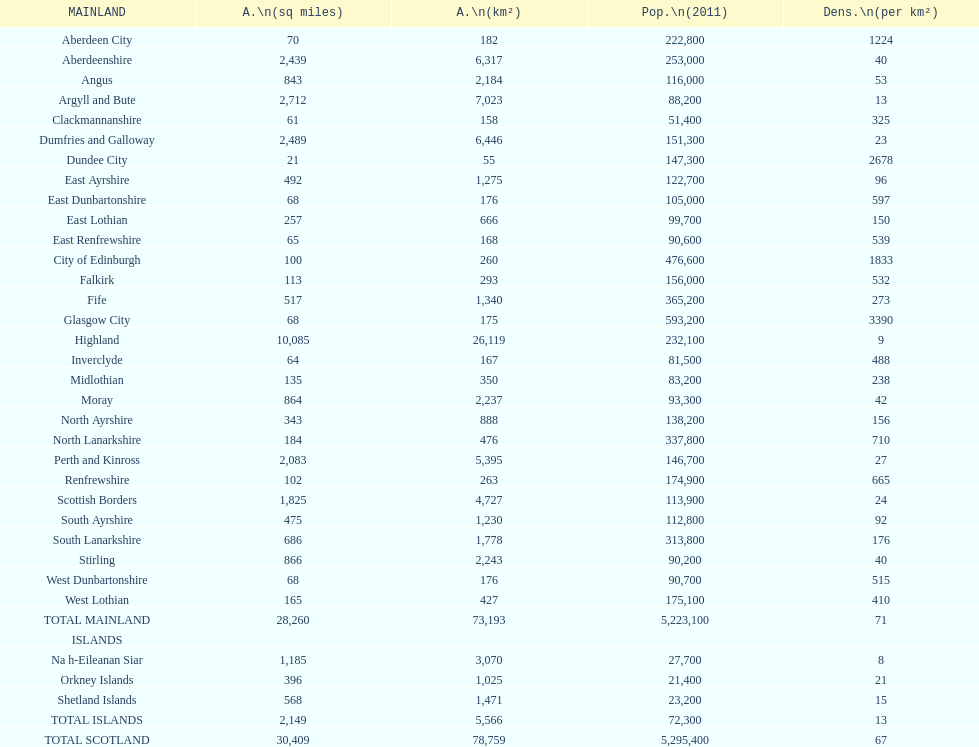Which mainland has the least population? Clackmannanshire. 